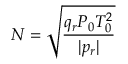<formula> <loc_0><loc_0><loc_500><loc_500>N = \sqrt { \frac { q _ { r } P _ { 0 } T _ { 0 } ^ { 2 } } { | p _ { r } | } }</formula> 